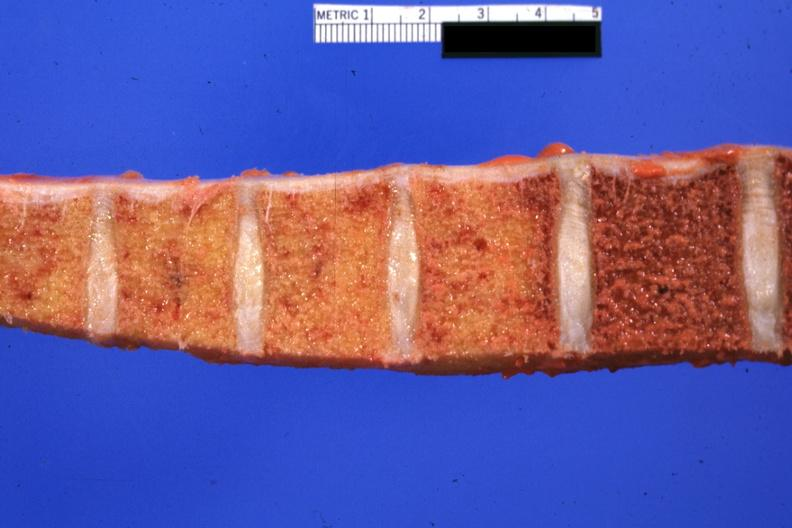what is present?
Answer the question using a single word or phrase. Joints 